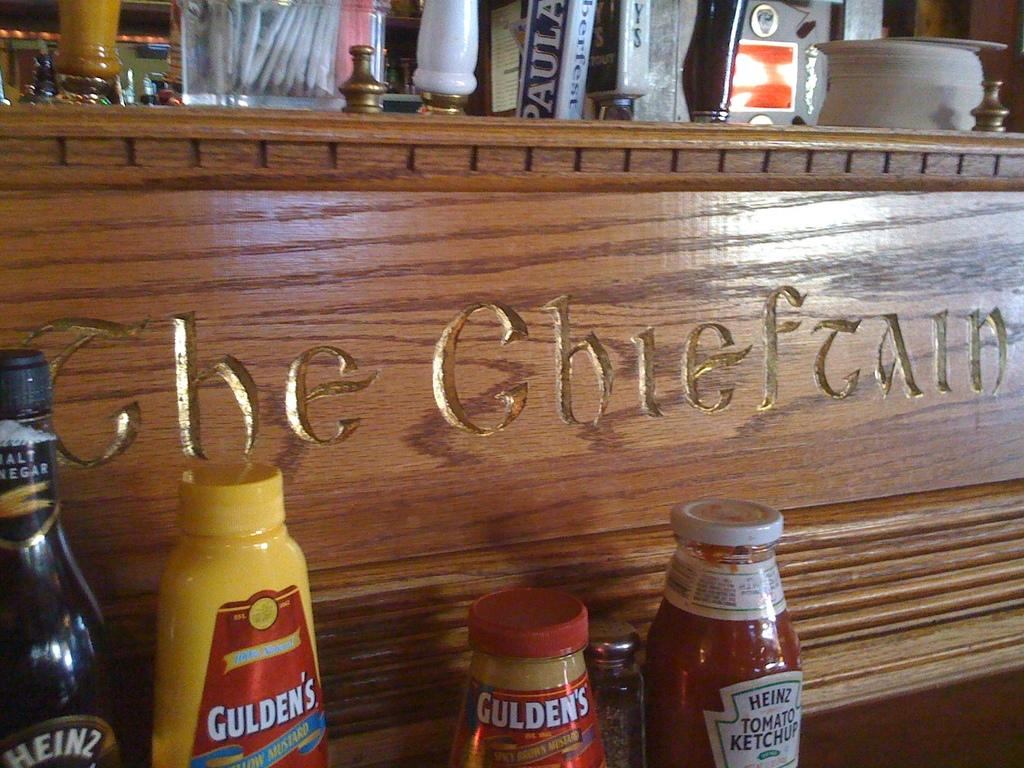<image>
Write a terse but informative summary of the picture. A variety of condiments like heinz branded tomato ketchup are arranged next to a wooden panel. 